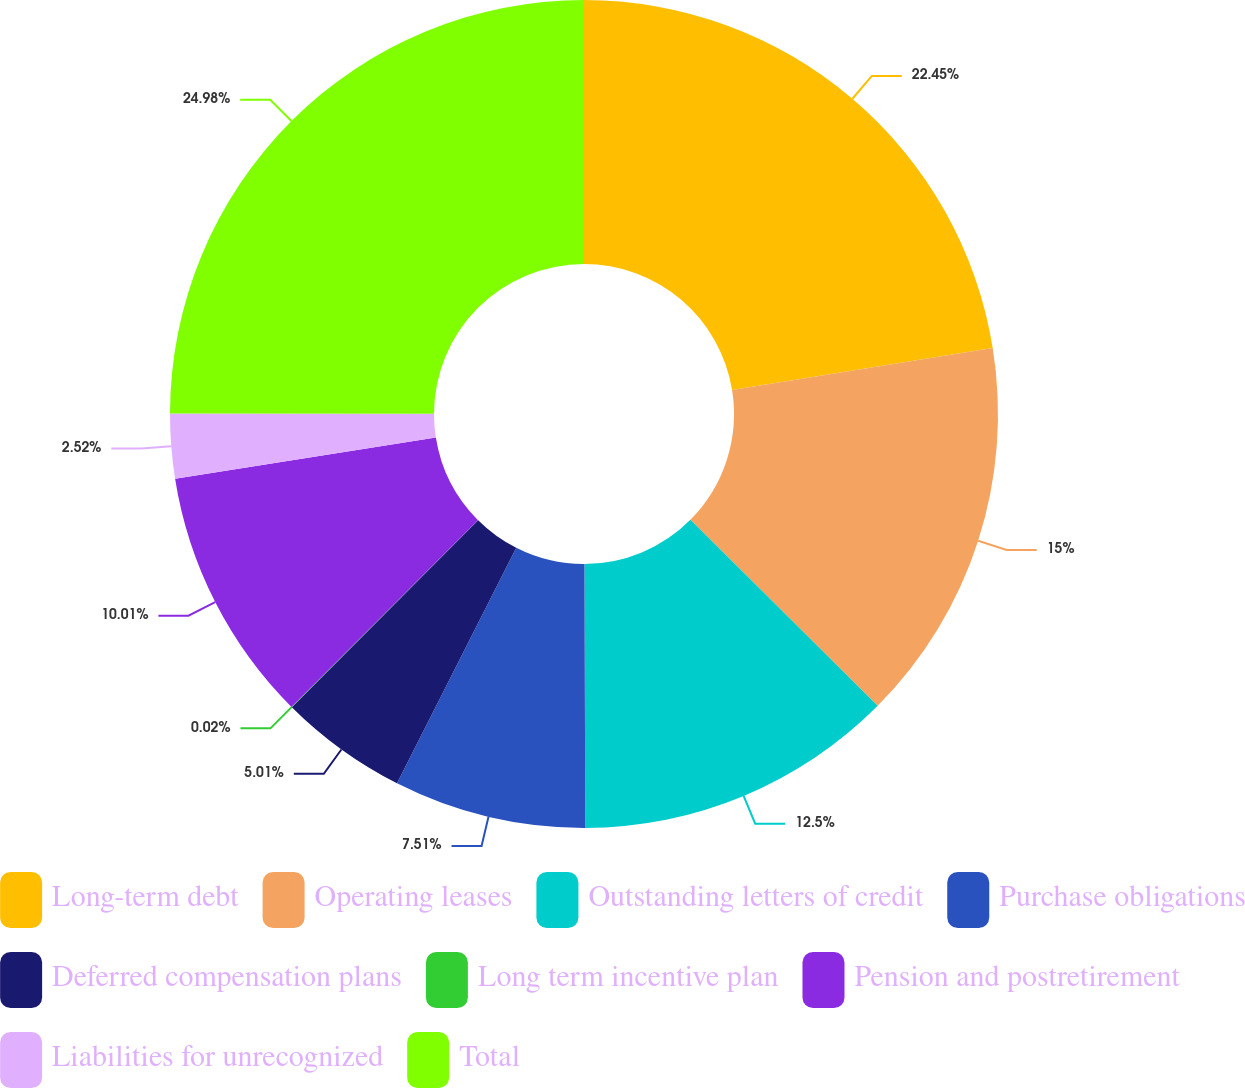Convert chart. <chart><loc_0><loc_0><loc_500><loc_500><pie_chart><fcel>Long-term debt<fcel>Operating leases<fcel>Outstanding letters of credit<fcel>Purchase obligations<fcel>Deferred compensation plans<fcel>Long term incentive plan<fcel>Pension and postretirement<fcel>Liabilities for unrecognized<fcel>Total<nl><fcel>22.45%<fcel>15.0%<fcel>12.5%<fcel>7.51%<fcel>5.01%<fcel>0.02%<fcel>10.01%<fcel>2.52%<fcel>24.98%<nl></chart> 